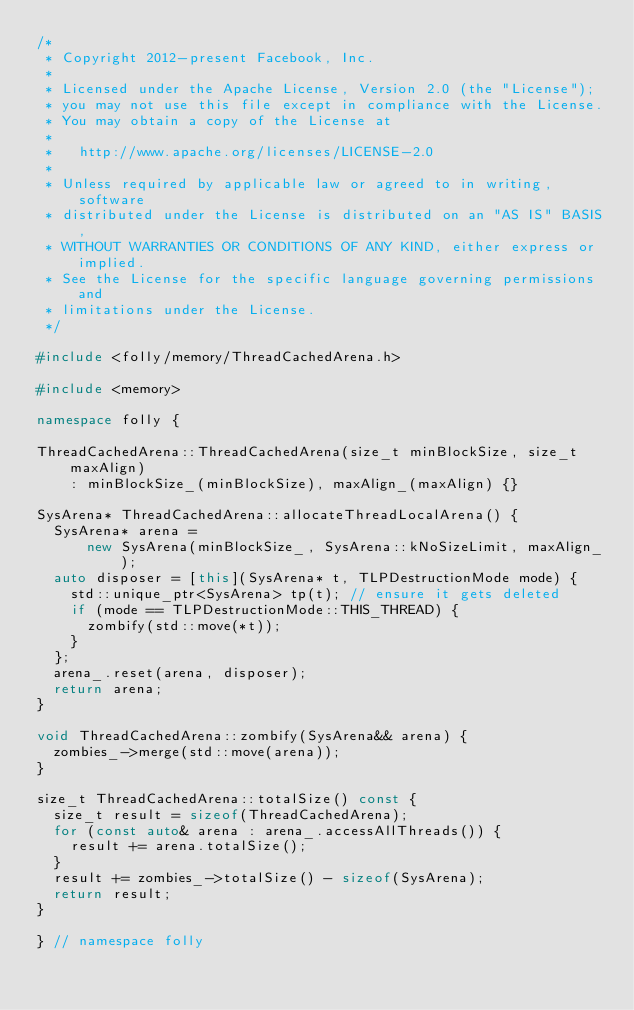Convert code to text. <code><loc_0><loc_0><loc_500><loc_500><_C++_>/*
 * Copyright 2012-present Facebook, Inc.
 *
 * Licensed under the Apache License, Version 2.0 (the "License");
 * you may not use this file except in compliance with the License.
 * You may obtain a copy of the License at
 *
 *   http://www.apache.org/licenses/LICENSE-2.0
 *
 * Unless required by applicable law or agreed to in writing, software
 * distributed under the License is distributed on an "AS IS" BASIS,
 * WITHOUT WARRANTIES OR CONDITIONS OF ANY KIND, either express or implied.
 * See the License for the specific language governing permissions and
 * limitations under the License.
 */

#include <folly/memory/ThreadCachedArena.h>

#include <memory>

namespace folly {

ThreadCachedArena::ThreadCachedArena(size_t minBlockSize, size_t maxAlign)
    : minBlockSize_(minBlockSize), maxAlign_(maxAlign) {}

SysArena* ThreadCachedArena::allocateThreadLocalArena() {
  SysArena* arena =
      new SysArena(minBlockSize_, SysArena::kNoSizeLimit, maxAlign_);
  auto disposer = [this](SysArena* t, TLPDestructionMode mode) {
    std::unique_ptr<SysArena> tp(t); // ensure it gets deleted
    if (mode == TLPDestructionMode::THIS_THREAD) {
      zombify(std::move(*t));
    }
  };
  arena_.reset(arena, disposer);
  return arena;
}

void ThreadCachedArena::zombify(SysArena&& arena) {
  zombies_->merge(std::move(arena));
}

size_t ThreadCachedArena::totalSize() const {
  size_t result = sizeof(ThreadCachedArena);
  for (const auto& arena : arena_.accessAllThreads()) {
    result += arena.totalSize();
  }
  result += zombies_->totalSize() - sizeof(SysArena);
  return result;
}

} // namespace folly
</code> 